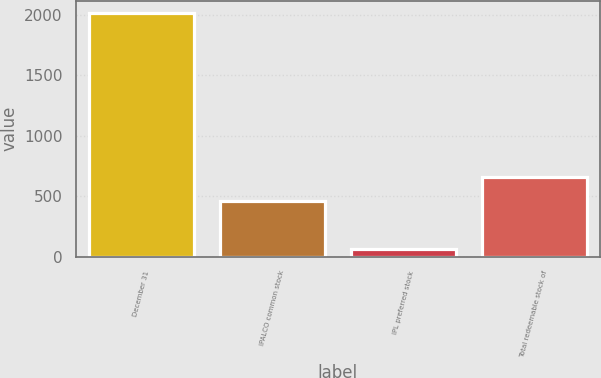Convert chart to OTSL. <chart><loc_0><loc_0><loc_500><loc_500><bar_chart><fcel>December 31<fcel>IPALCO common stock<fcel>IPL preferred stock<fcel>Total redeemable stock of<nl><fcel>2015<fcel>460<fcel>60<fcel>655.5<nl></chart> 